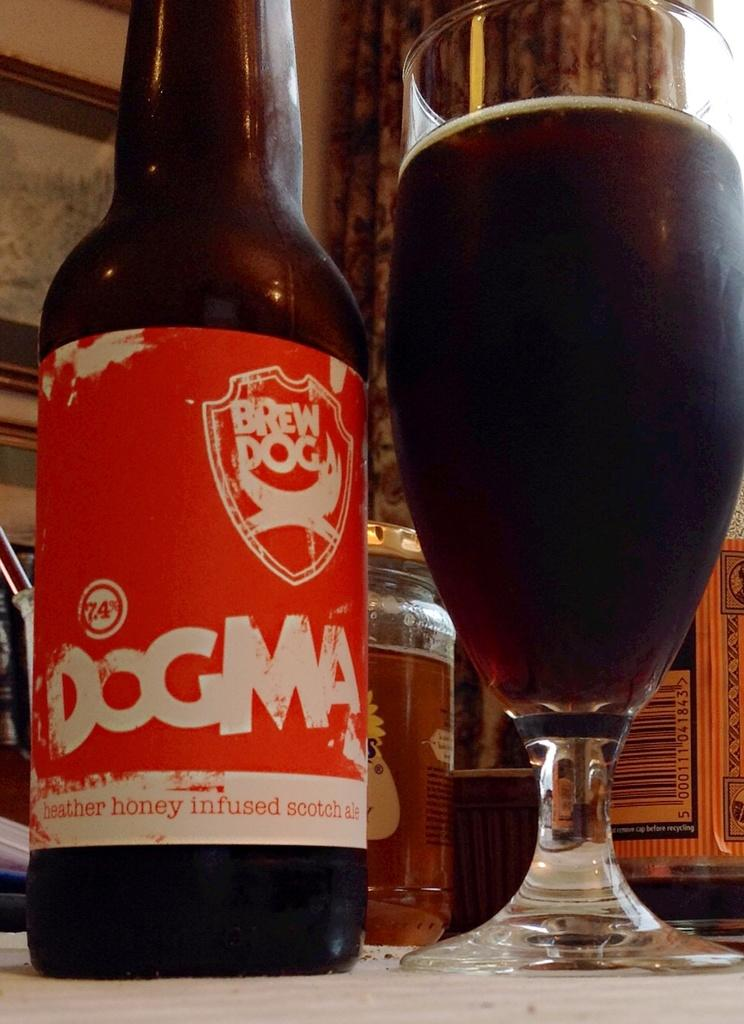<image>
Give a short and clear explanation of the subsequent image. a bottle of Dogman heather honey infused scotch ale 